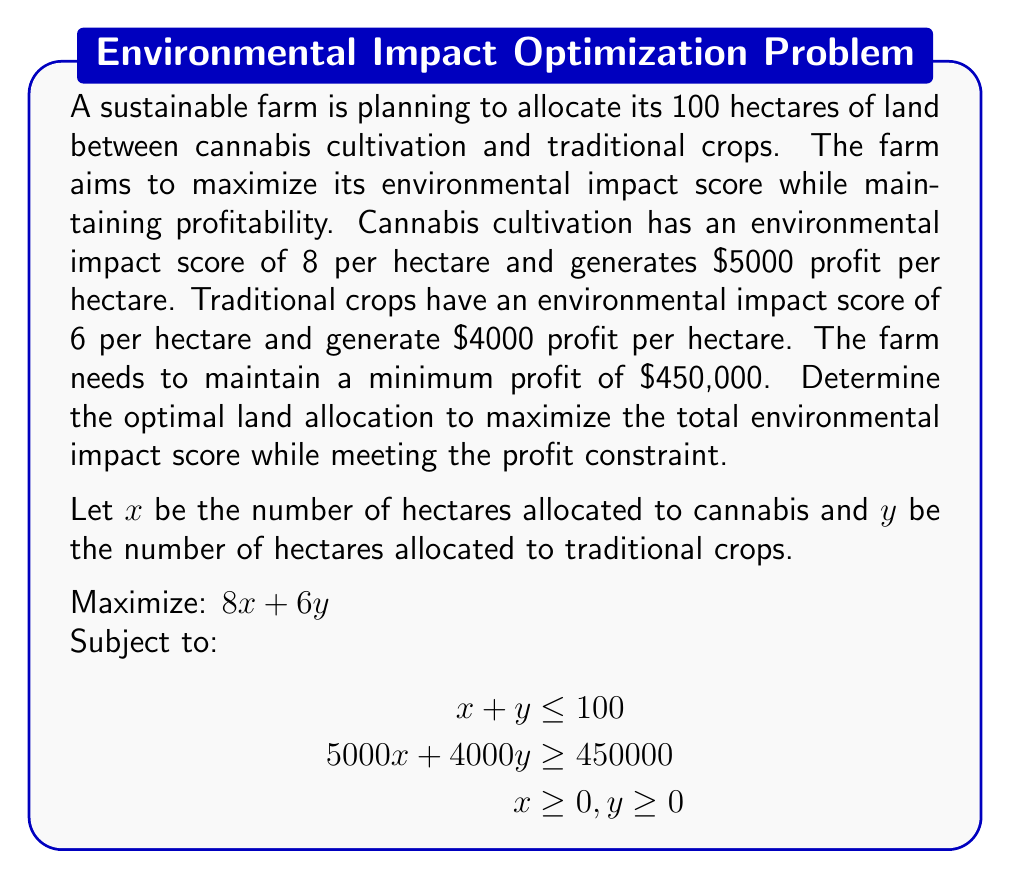What is the answer to this math problem? To solve this linear programming problem, we'll use the graphical method:

1. Plot the constraints:
   a. $x + y = 100$ (land constraint)
   b. $5000x + 4000y = 450000$ (profit constraint)
   c. $x \geq 0, y \geq 0$ (non-negativity constraints)

2. Identify the feasible region:
   The feasible region is the area that satisfies all constraints.

3. Find the corner points of the feasible region:
   A: (0, 100) - intersection of $y$-axis and land constraint
   B: (90, 10) - intersection of land and profit constraints
   C: (100, 0) - intersection of $x$-axis and land constraint

4. Evaluate the objective function at each corner point:
   A: $8(0) + 6(100) = 600$
   B: $8(90) + 6(10) = 780$
   C: $8(100) + 6(0) = 800$

5. The maximum value of the objective function occurs at point C (100, 0).

6. Check if point C satisfies the profit constraint:
   $5000(100) + 4000(0) = 500000 > 450000$

Therefore, the optimal solution is to allocate all 100 hectares to cannabis cultivation.

[asy]
unitsize(2mm);
draw((0,0)--(100,0), arrow=Arrow(TeXHead));
draw((0,0)--(0,100), arrow=Arrow(TeXHead));
label("$x$", (100,0), SE);
label("$y$", (0,100), NW);
draw((0,100)--(100,0), blue);
draw((0,112.5)--(90,10), red);
fill((0,0)--(90,10)--(100,0)--cycle, lightgreen+opacity(0.2));
label("A", (0,100), W);
label("B", (90,10), E);
label("C", (100,0), S);
label("$x+y=100$", (50,50), NW, blue);
label("$5000x+4000y=450000$", (45,70), SE, red);
[/asy]
Answer: The optimal land allocation is 100 hectares for cannabis cultivation and 0 hectares for traditional crops, resulting in a maximum environmental impact score of 800. 